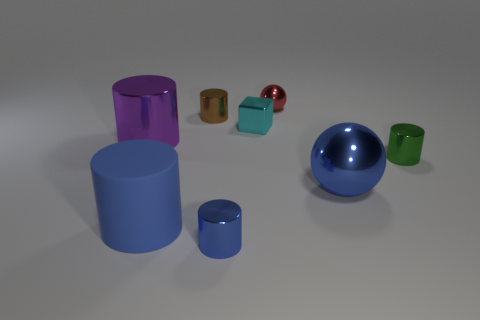Subtract all big blue cylinders. How many cylinders are left? 4 Add 1 tiny brown cylinders. How many objects exist? 9 Subtract all spheres. How many objects are left? 6 Subtract all blue cylinders. How many cylinders are left? 3 Subtract 1 blocks. How many blocks are left? 0 Subtract all brown spheres. Subtract all blue blocks. How many spheres are left? 2 Subtract all green balls. How many brown blocks are left? 0 Subtract all cyan spheres. Subtract all rubber objects. How many objects are left? 7 Add 7 metal cubes. How many metal cubes are left? 8 Add 5 big blue things. How many big blue things exist? 7 